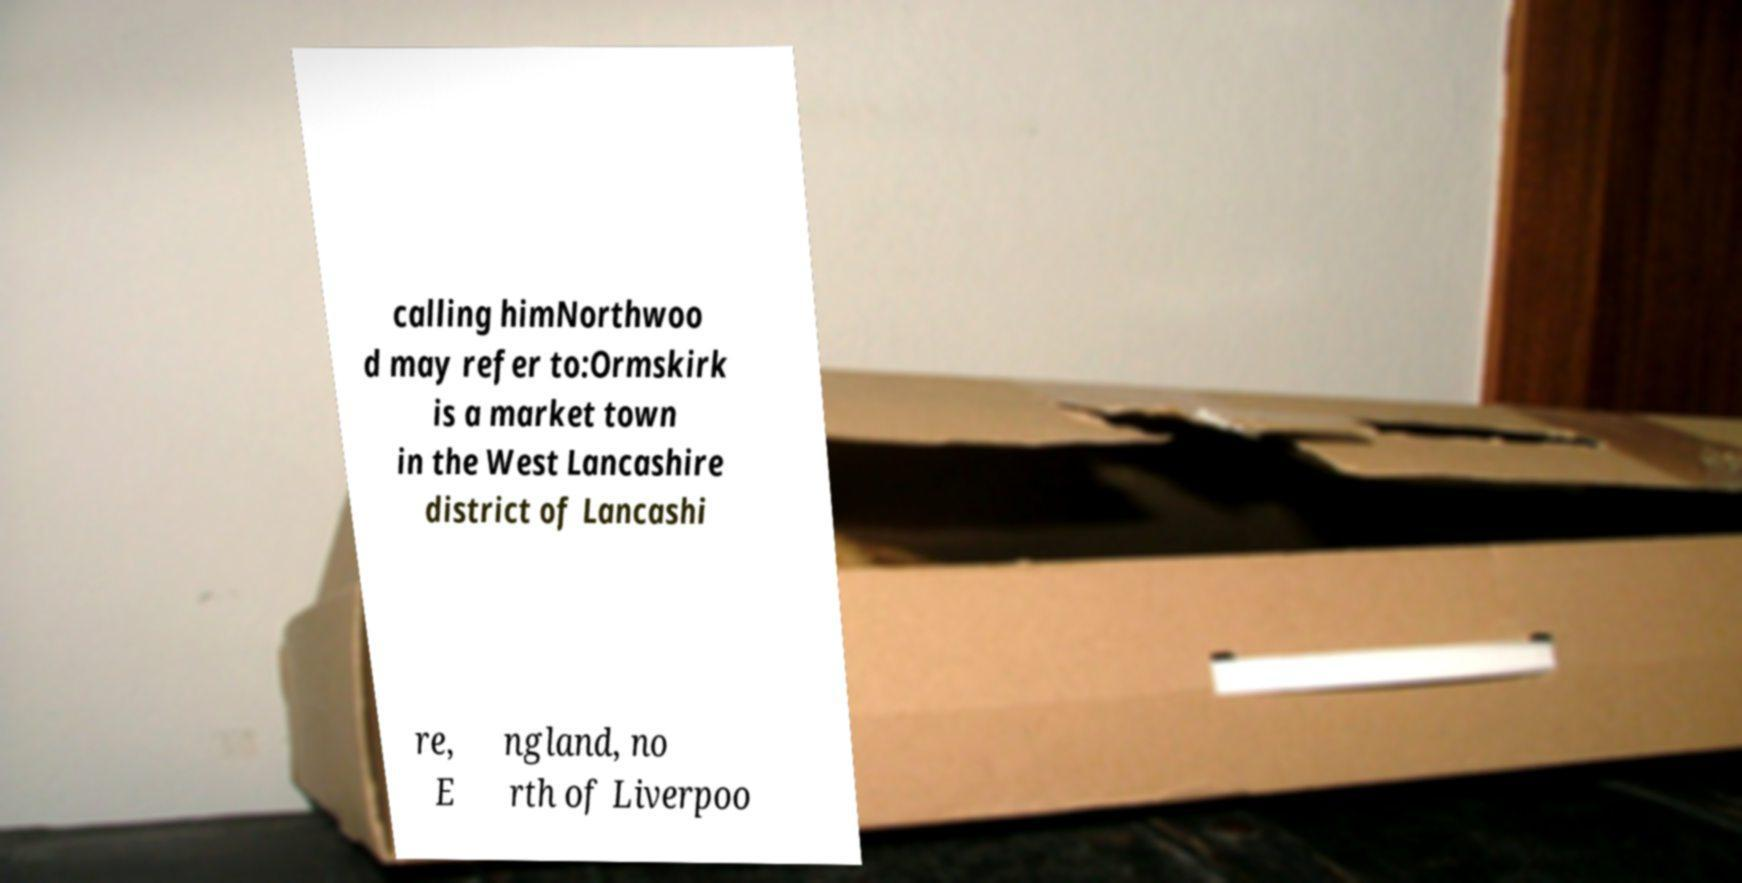Please read and relay the text visible in this image. What does it say? calling himNorthwoo d may refer to:Ormskirk is a market town in the West Lancashire district of Lancashi re, E ngland, no rth of Liverpoo 